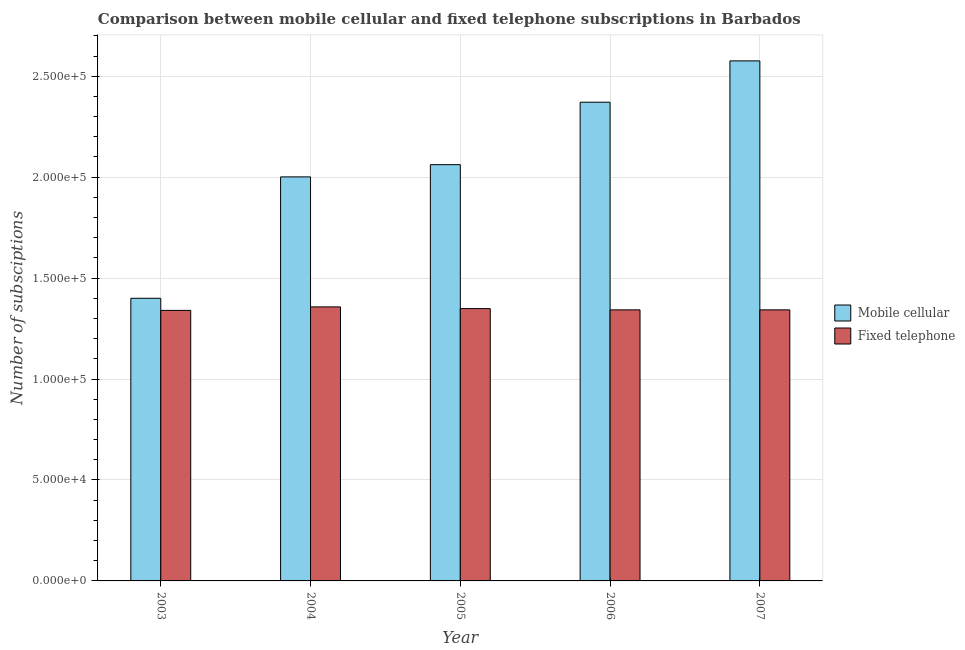How many different coloured bars are there?
Ensure brevity in your answer.  2. How many groups of bars are there?
Your answer should be compact. 5. Are the number of bars per tick equal to the number of legend labels?
Your answer should be compact. Yes. Are the number of bars on each tick of the X-axis equal?
Offer a terse response. Yes. How many bars are there on the 4th tick from the left?
Your response must be concise. 2. In how many cases, is the number of bars for a given year not equal to the number of legend labels?
Ensure brevity in your answer.  0. What is the number of fixed telephone subscriptions in 2004?
Ensure brevity in your answer.  1.36e+05. Across all years, what is the maximum number of fixed telephone subscriptions?
Provide a succinct answer. 1.36e+05. Across all years, what is the minimum number of mobile cellular subscriptions?
Your answer should be very brief. 1.40e+05. In which year was the number of mobile cellular subscriptions maximum?
Make the answer very short. 2007. In which year was the number of fixed telephone subscriptions minimum?
Provide a succinct answer. 2003. What is the total number of mobile cellular subscriptions in the graph?
Ensure brevity in your answer.  1.04e+06. What is the difference between the number of fixed telephone subscriptions in 2003 and that in 2004?
Keep it short and to the point. -1732. What is the difference between the number of fixed telephone subscriptions in 2003 and the number of mobile cellular subscriptions in 2004?
Provide a succinct answer. -1732. What is the average number of mobile cellular subscriptions per year?
Make the answer very short. 2.08e+05. What is the ratio of the number of fixed telephone subscriptions in 2005 to that in 2007?
Provide a short and direct response. 1. Is the difference between the number of mobile cellular subscriptions in 2005 and 2007 greater than the difference between the number of fixed telephone subscriptions in 2005 and 2007?
Your response must be concise. No. What is the difference between the highest and the second highest number of mobile cellular subscriptions?
Provide a short and direct response. 2.05e+04. What is the difference between the highest and the lowest number of fixed telephone subscriptions?
Make the answer very short. 1732. In how many years, is the number of fixed telephone subscriptions greater than the average number of fixed telephone subscriptions taken over all years?
Make the answer very short. 2. What does the 1st bar from the left in 2006 represents?
Provide a succinct answer. Mobile cellular. What does the 1st bar from the right in 2007 represents?
Your answer should be compact. Fixed telephone. How many bars are there?
Your answer should be compact. 10. How many years are there in the graph?
Provide a short and direct response. 5. What is the difference between two consecutive major ticks on the Y-axis?
Give a very brief answer. 5.00e+04. Are the values on the major ticks of Y-axis written in scientific E-notation?
Your answer should be very brief. Yes. Where does the legend appear in the graph?
Give a very brief answer. Center right. What is the title of the graph?
Your answer should be compact. Comparison between mobile cellular and fixed telephone subscriptions in Barbados. Does "Boys" appear as one of the legend labels in the graph?
Make the answer very short. No. What is the label or title of the Y-axis?
Offer a terse response. Number of subsciptions. What is the Number of subsciptions of Fixed telephone in 2003?
Your response must be concise. 1.34e+05. What is the Number of subsciptions of Mobile cellular in 2004?
Offer a terse response. 2.00e+05. What is the Number of subsciptions in Fixed telephone in 2004?
Provide a succinct answer. 1.36e+05. What is the Number of subsciptions of Mobile cellular in 2005?
Your response must be concise. 2.06e+05. What is the Number of subsciptions of Fixed telephone in 2005?
Keep it short and to the point. 1.35e+05. What is the Number of subsciptions in Mobile cellular in 2006?
Ensure brevity in your answer.  2.37e+05. What is the Number of subsciptions of Fixed telephone in 2006?
Your answer should be very brief. 1.34e+05. What is the Number of subsciptions in Mobile cellular in 2007?
Your answer should be very brief. 2.58e+05. What is the Number of subsciptions in Fixed telephone in 2007?
Your response must be concise. 1.34e+05. Across all years, what is the maximum Number of subsciptions of Mobile cellular?
Your response must be concise. 2.58e+05. Across all years, what is the maximum Number of subsciptions of Fixed telephone?
Keep it short and to the point. 1.36e+05. Across all years, what is the minimum Number of subsciptions in Mobile cellular?
Offer a terse response. 1.40e+05. Across all years, what is the minimum Number of subsciptions of Fixed telephone?
Offer a very short reply. 1.34e+05. What is the total Number of subsciptions of Mobile cellular in the graph?
Provide a short and direct response. 1.04e+06. What is the total Number of subsciptions of Fixed telephone in the graph?
Make the answer very short. 6.73e+05. What is the difference between the Number of subsciptions in Mobile cellular in 2003 and that in 2004?
Your answer should be very brief. -6.01e+04. What is the difference between the Number of subsciptions of Fixed telephone in 2003 and that in 2004?
Make the answer very short. -1732. What is the difference between the Number of subsciptions of Mobile cellular in 2003 and that in 2005?
Give a very brief answer. -6.62e+04. What is the difference between the Number of subsciptions of Fixed telephone in 2003 and that in 2005?
Your answer should be very brief. -878. What is the difference between the Number of subsciptions of Mobile cellular in 2003 and that in 2006?
Keep it short and to the point. -9.71e+04. What is the difference between the Number of subsciptions of Fixed telephone in 2003 and that in 2006?
Your response must be concise. -261. What is the difference between the Number of subsciptions of Mobile cellular in 2003 and that in 2007?
Your answer should be very brief. -1.18e+05. What is the difference between the Number of subsciptions of Fixed telephone in 2003 and that in 2007?
Offer a very short reply. -261. What is the difference between the Number of subsciptions of Mobile cellular in 2004 and that in 2005?
Your response must be concise. -6052. What is the difference between the Number of subsciptions of Fixed telephone in 2004 and that in 2005?
Offer a very short reply. 854. What is the difference between the Number of subsciptions of Mobile cellular in 2004 and that in 2006?
Provide a short and direct response. -3.70e+04. What is the difference between the Number of subsciptions in Fixed telephone in 2004 and that in 2006?
Provide a short and direct response. 1471. What is the difference between the Number of subsciptions of Mobile cellular in 2004 and that in 2007?
Offer a very short reply. -5.75e+04. What is the difference between the Number of subsciptions of Fixed telephone in 2004 and that in 2007?
Ensure brevity in your answer.  1471. What is the difference between the Number of subsciptions of Mobile cellular in 2005 and that in 2006?
Provide a succinct answer. -3.09e+04. What is the difference between the Number of subsciptions in Fixed telephone in 2005 and that in 2006?
Offer a terse response. 617. What is the difference between the Number of subsciptions of Mobile cellular in 2005 and that in 2007?
Your answer should be very brief. -5.14e+04. What is the difference between the Number of subsciptions of Fixed telephone in 2005 and that in 2007?
Your answer should be compact. 617. What is the difference between the Number of subsciptions in Mobile cellular in 2006 and that in 2007?
Make the answer very short. -2.05e+04. What is the difference between the Number of subsciptions of Fixed telephone in 2006 and that in 2007?
Your response must be concise. 0. What is the difference between the Number of subsciptions in Mobile cellular in 2003 and the Number of subsciptions in Fixed telephone in 2004?
Your answer should be very brief. 4268. What is the difference between the Number of subsciptions of Mobile cellular in 2003 and the Number of subsciptions of Fixed telephone in 2005?
Ensure brevity in your answer.  5122. What is the difference between the Number of subsciptions of Mobile cellular in 2003 and the Number of subsciptions of Fixed telephone in 2006?
Make the answer very short. 5739. What is the difference between the Number of subsciptions of Mobile cellular in 2003 and the Number of subsciptions of Fixed telephone in 2007?
Your answer should be very brief. 5739. What is the difference between the Number of subsciptions of Mobile cellular in 2004 and the Number of subsciptions of Fixed telephone in 2005?
Your response must be concise. 6.53e+04. What is the difference between the Number of subsciptions of Mobile cellular in 2004 and the Number of subsciptions of Fixed telephone in 2006?
Your response must be concise. 6.59e+04. What is the difference between the Number of subsciptions in Mobile cellular in 2004 and the Number of subsciptions in Fixed telephone in 2007?
Ensure brevity in your answer.  6.59e+04. What is the difference between the Number of subsciptions in Mobile cellular in 2005 and the Number of subsciptions in Fixed telephone in 2006?
Give a very brief answer. 7.19e+04. What is the difference between the Number of subsciptions of Mobile cellular in 2005 and the Number of subsciptions of Fixed telephone in 2007?
Your answer should be compact. 7.19e+04. What is the difference between the Number of subsciptions of Mobile cellular in 2006 and the Number of subsciptions of Fixed telephone in 2007?
Provide a short and direct response. 1.03e+05. What is the average Number of subsciptions in Mobile cellular per year?
Your answer should be compact. 2.08e+05. What is the average Number of subsciptions in Fixed telephone per year?
Provide a succinct answer. 1.35e+05. In the year 2003, what is the difference between the Number of subsciptions of Mobile cellular and Number of subsciptions of Fixed telephone?
Provide a succinct answer. 6000. In the year 2004, what is the difference between the Number of subsciptions in Mobile cellular and Number of subsciptions in Fixed telephone?
Offer a very short reply. 6.44e+04. In the year 2005, what is the difference between the Number of subsciptions in Mobile cellular and Number of subsciptions in Fixed telephone?
Provide a succinct answer. 7.13e+04. In the year 2006, what is the difference between the Number of subsciptions of Mobile cellular and Number of subsciptions of Fixed telephone?
Provide a succinct answer. 1.03e+05. In the year 2007, what is the difference between the Number of subsciptions in Mobile cellular and Number of subsciptions in Fixed telephone?
Make the answer very short. 1.23e+05. What is the ratio of the Number of subsciptions of Mobile cellular in 2003 to that in 2004?
Your response must be concise. 0.7. What is the ratio of the Number of subsciptions in Fixed telephone in 2003 to that in 2004?
Make the answer very short. 0.99. What is the ratio of the Number of subsciptions in Mobile cellular in 2003 to that in 2005?
Give a very brief answer. 0.68. What is the ratio of the Number of subsciptions of Fixed telephone in 2003 to that in 2005?
Your response must be concise. 0.99. What is the ratio of the Number of subsciptions in Mobile cellular in 2003 to that in 2006?
Ensure brevity in your answer.  0.59. What is the ratio of the Number of subsciptions of Fixed telephone in 2003 to that in 2006?
Offer a terse response. 1. What is the ratio of the Number of subsciptions of Mobile cellular in 2003 to that in 2007?
Your response must be concise. 0.54. What is the ratio of the Number of subsciptions of Fixed telephone in 2003 to that in 2007?
Make the answer very short. 1. What is the ratio of the Number of subsciptions of Mobile cellular in 2004 to that in 2005?
Ensure brevity in your answer.  0.97. What is the ratio of the Number of subsciptions in Mobile cellular in 2004 to that in 2006?
Your answer should be compact. 0.84. What is the ratio of the Number of subsciptions in Mobile cellular in 2004 to that in 2007?
Keep it short and to the point. 0.78. What is the ratio of the Number of subsciptions of Mobile cellular in 2005 to that in 2006?
Make the answer very short. 0.87. What is the ratio of the Number of subsciptions in Fixed telephone in 2005 to that in 2006?
Your response must be concise. 1. What is the ratio of the Number of subsciptions of Mobile cellular in 2005 to that in 2007?
Your answer should be very brief. 0.8. What is the ratio of the Number of subsciptions of Mobile cellular in 2006 to that in 2007?
Make the answer very short. 0.92. What is the difference between the highest and the second highest Number of subsciptions of Mobile cellular?
Provide a succinct answer. 2.05e+04. What is the difference between the highest and the second highest Number of subsciptions in Fixed telephone?
Give a very brief answer. 854. What is the difference between the highest and the lowest Number of subsciptions in Mobile cellular?
Offer a very short reply. 1.18e+05. What is the difference between the highest and the lowest Number of subsciptions of Fixed telephone?
Your answer should be compact. 1732. 